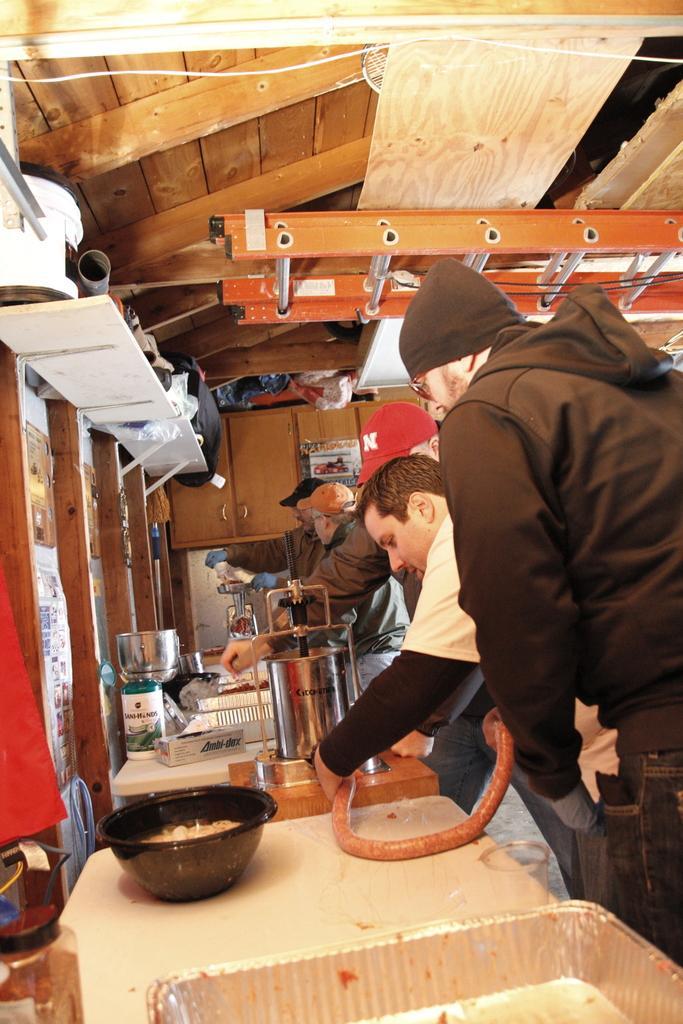In one or two sentences, can you explain what this image depicts? On this platform there are containers, bowl and things. Beside this platform there are people. Pictures are on the wall. Poster is on cupboard. This is ladder.  